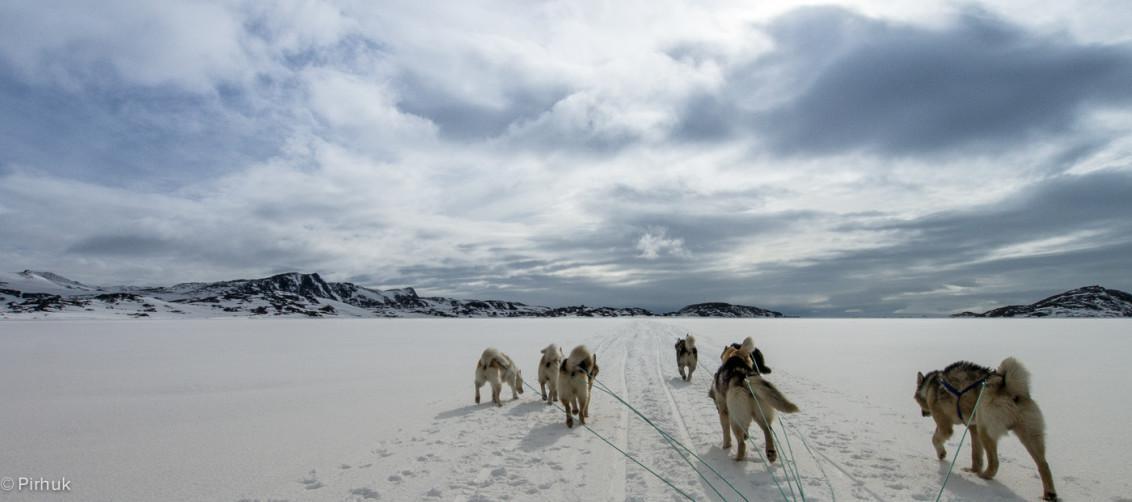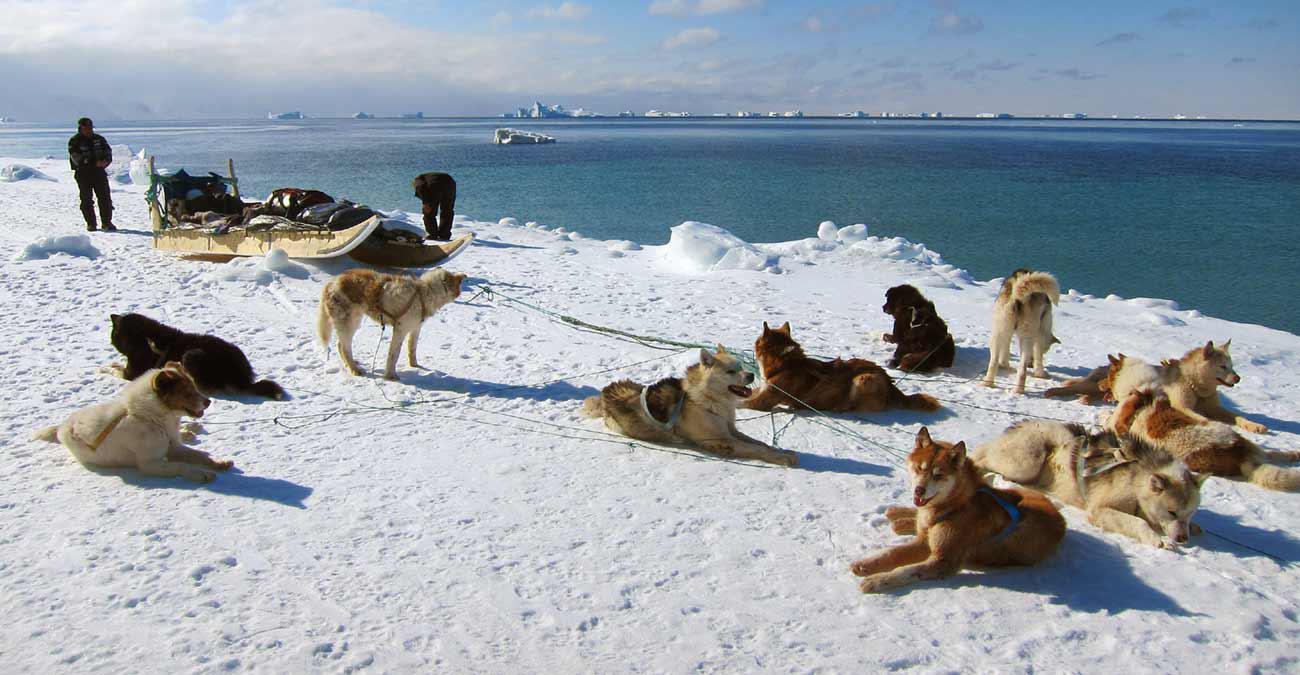The first image is the image on the left, the second image is the image on the right. For the images shown, is this caption "There are dogs resting." true? Answer yes or no. Yes. The first image is the image on the left, the second image is the image on the right. Given the left and right images, does the statement "Some of the dogs are sitting." hold true? Answer yes or no. Yes. 